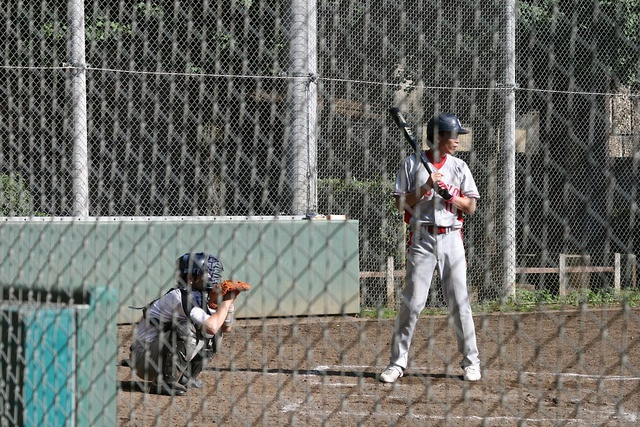Describe the objects in this image and their specific colors. I can see people in purple, lightgray, gray, darkgray, and black tones, people in purple, gray, black, darkgray, and lightgray tones, baseball glove in purple, maroon, black, gray, and brown tones, and baseball bat in purple, black, gray, darkgray, and lightgray tones in this image. 